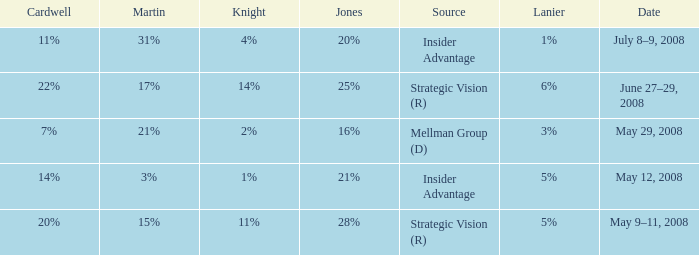What Lanier has a Cardwell of 20%? 5%. 